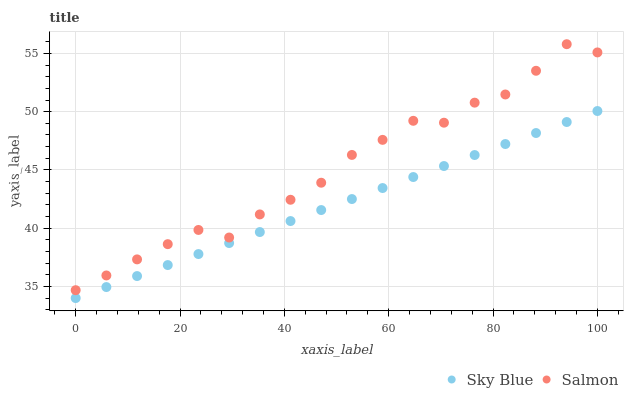Does Sky Blue have the minimum area under the curve?
Answer yes or no. Yes. Does Salmon have the maximum area under the curve?
Answer yes or no. Yes. Does Salmon have the minimum area under the curve?
Answer yes or no. No. Is Sky Blue the smoothest?
Answer yes or no. Yes. Is Salmon the roughest?
Answer yes or no. Yes. Is Salmon the smoothest?
Answer yes or no. No. Does Sky Blue have the lowest value?
Answer yes or no. Yes. Does Salmon have the lowest value?
Answer yes or no. No. Does Salmon have the highest value?
Answer yes or no. Yes. Is Sky Blue less than Salmon?
Answer yes or no. Yes. Is Salmon greater than Sky Blue?
Answer yes or no. Yes. Does Sky Blue intersect Salmon?
Answer yes or no. No. 